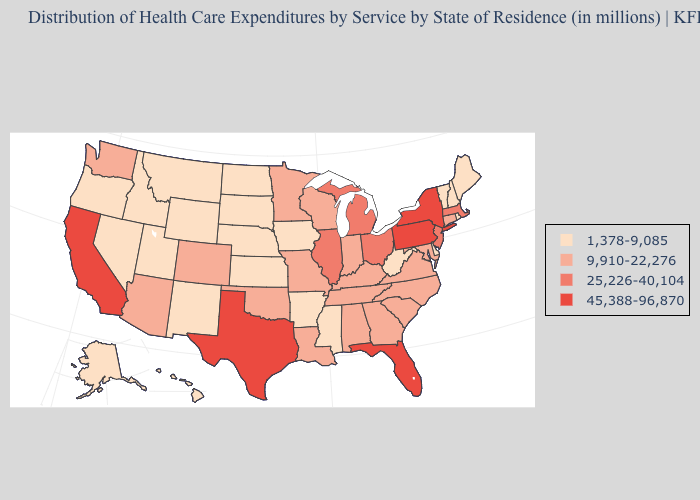Does New York have the highest value in the USA?
Answer briefly. Yes. What is the value of Massachusetts?
Be succinct. 25,226-40,104. Name the states that have a value in the range 45,388-96,870?
Write a very short answer. California, Florida, New York, Pennsylvania, Texas. What is the highest value in states that border Colorado?
Short answer required. 9,910-22,276. Name the states that have a value in the range 1,378-9,085?
Be succinct. Alaska, Arkansas, Delaware, Hawaii, Idaho, Iowa, Kansas, Maine, Mississippi, Montana, Nebraska, Nevada, New Hampshire, New Mexico, North Dakota, Oregon, Rhode Island, South Dakota, Utah, Vermont, West Virginia, Wyoming. Does Texas have the highest value in the USA?
Answer briefly. Yes. How many symbols are there in the legend?
Give a very brief answer. 4. What is the lowest value in states that border Arizona?
Keep it brief. 1,378-9,085. Does Missouri have the lowest value in the USA?
Concise answer only. No. Name the states that have a value in the range 1,378-9,085?
Give a very brief answer. Alaska, Arkansas, Delaware, Hawaii, Idaho, Iowa, Kansas, Maine, Mississippi, Montana, Nebraska, Nevada, New Hampshire, New Mexico, North Dakota, Oregon, Rhode Island, South Dakota, Utah, Vermont, West Virginia, Wyoming. Which states have the highest value in the USA?
Answer briefly. California, Florida, New York, Pennsylvania, Texas. Name the states that have a value in the range 1,378-9,085?
Concise answer only. Alaska, Arkansas, Delaware, Hawaii, Idaho, Iowa, Kansas, Maine, Mississippi, Montana, Nebraska, Nevada, New Hampshire, New Mexico, North Dakota, Oregon, Rhode Island, South Dakota, Utah, Vermont, West Virginia, Wyoming. Does Tennessee have the highest value in the South?
Be succinct. No. Among the states that border Maine , which have the lowest value?
Write a very short answer. New Hampshire. What is the value of Kansas?
Be succinct. 1,378-9,085. 